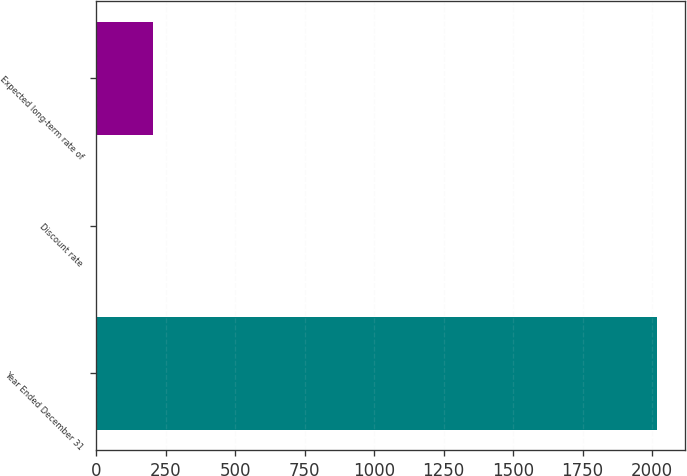Convert chart to OTSL. <chart><loc_0><loc_0><loc_500><loc_500><bar_chart><fcel>Year Ended December 31<fcel>Discount rate<fcel>Expected long-term rate of<nl><fcel>2017<fcel>4<fcel>205.3<nl></chart> 